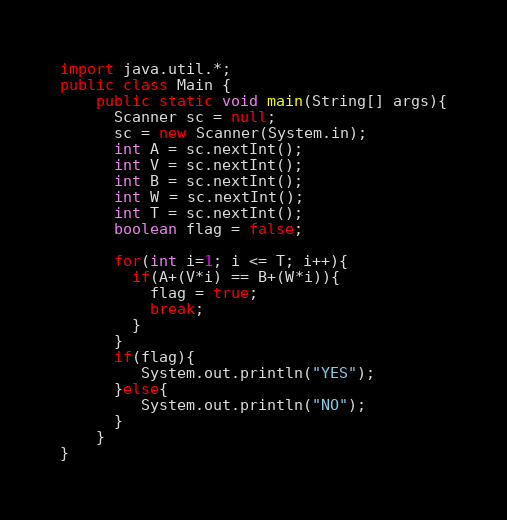<code> <loc_0><loc_0><loc_500><loc_500><_Java_>import java.util.*;
public class Main {
	public static void main(String[] args){
      Scanner sc = null;
      sc = new Scanner(System.in);
      int A = sc.nextInt();
      int V = sc.nextInt();
      int B = sc.nextInt();
      int W = sc.nextInt();
      int T = sc.nextInt();
      boolean flag = false;
      
      for(int i=1; i <= T; i++){
        if(A+(V*i) == B+(W*i)){
          flag = true;
          break;
        }
      }
      if(flag){
         System.out.println("YES");
      }else{
         System.out.println("NO");
      }
    }
}</code> 